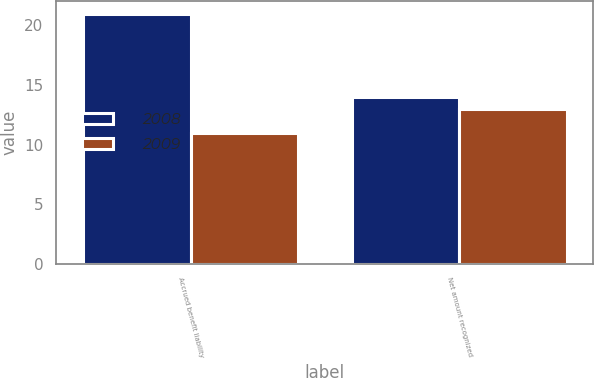<chart> <loc_0><loc_0><loc_500><loc_500><stacked_bar_chart><ecel><fcel>Accrued benefit liability<fcel>Net amount recognized<nl><fcel>2008<fcel>21<fcel>14<nl><fcel>2009<fcel>11<fcel>13<nl></chart> 